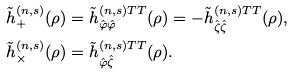<formula> <loc_0><loc_0><loc_500><loc_500>\tilde { h } _ { + } ^ { ( n , s ) } ( \rho ) & = \tilde { h } _ { \hat { \varphi } \hat { \varphi } } ^ { ( n , s ) T T } ( \rho ) = - \tilde { h } _ { \hat { \zeta } \hat { \zeta } } ^ { ( n , s ) T T } ( \rho ) , \\ \tilde { h } _ { \times } ^ { ( n , s ) } ( \rho ) & = \tilde { h } _ { \hat { \varphi } \hat { \zeta } } ^ { ( n , s ) T T } ( \rho ) .</formula> 